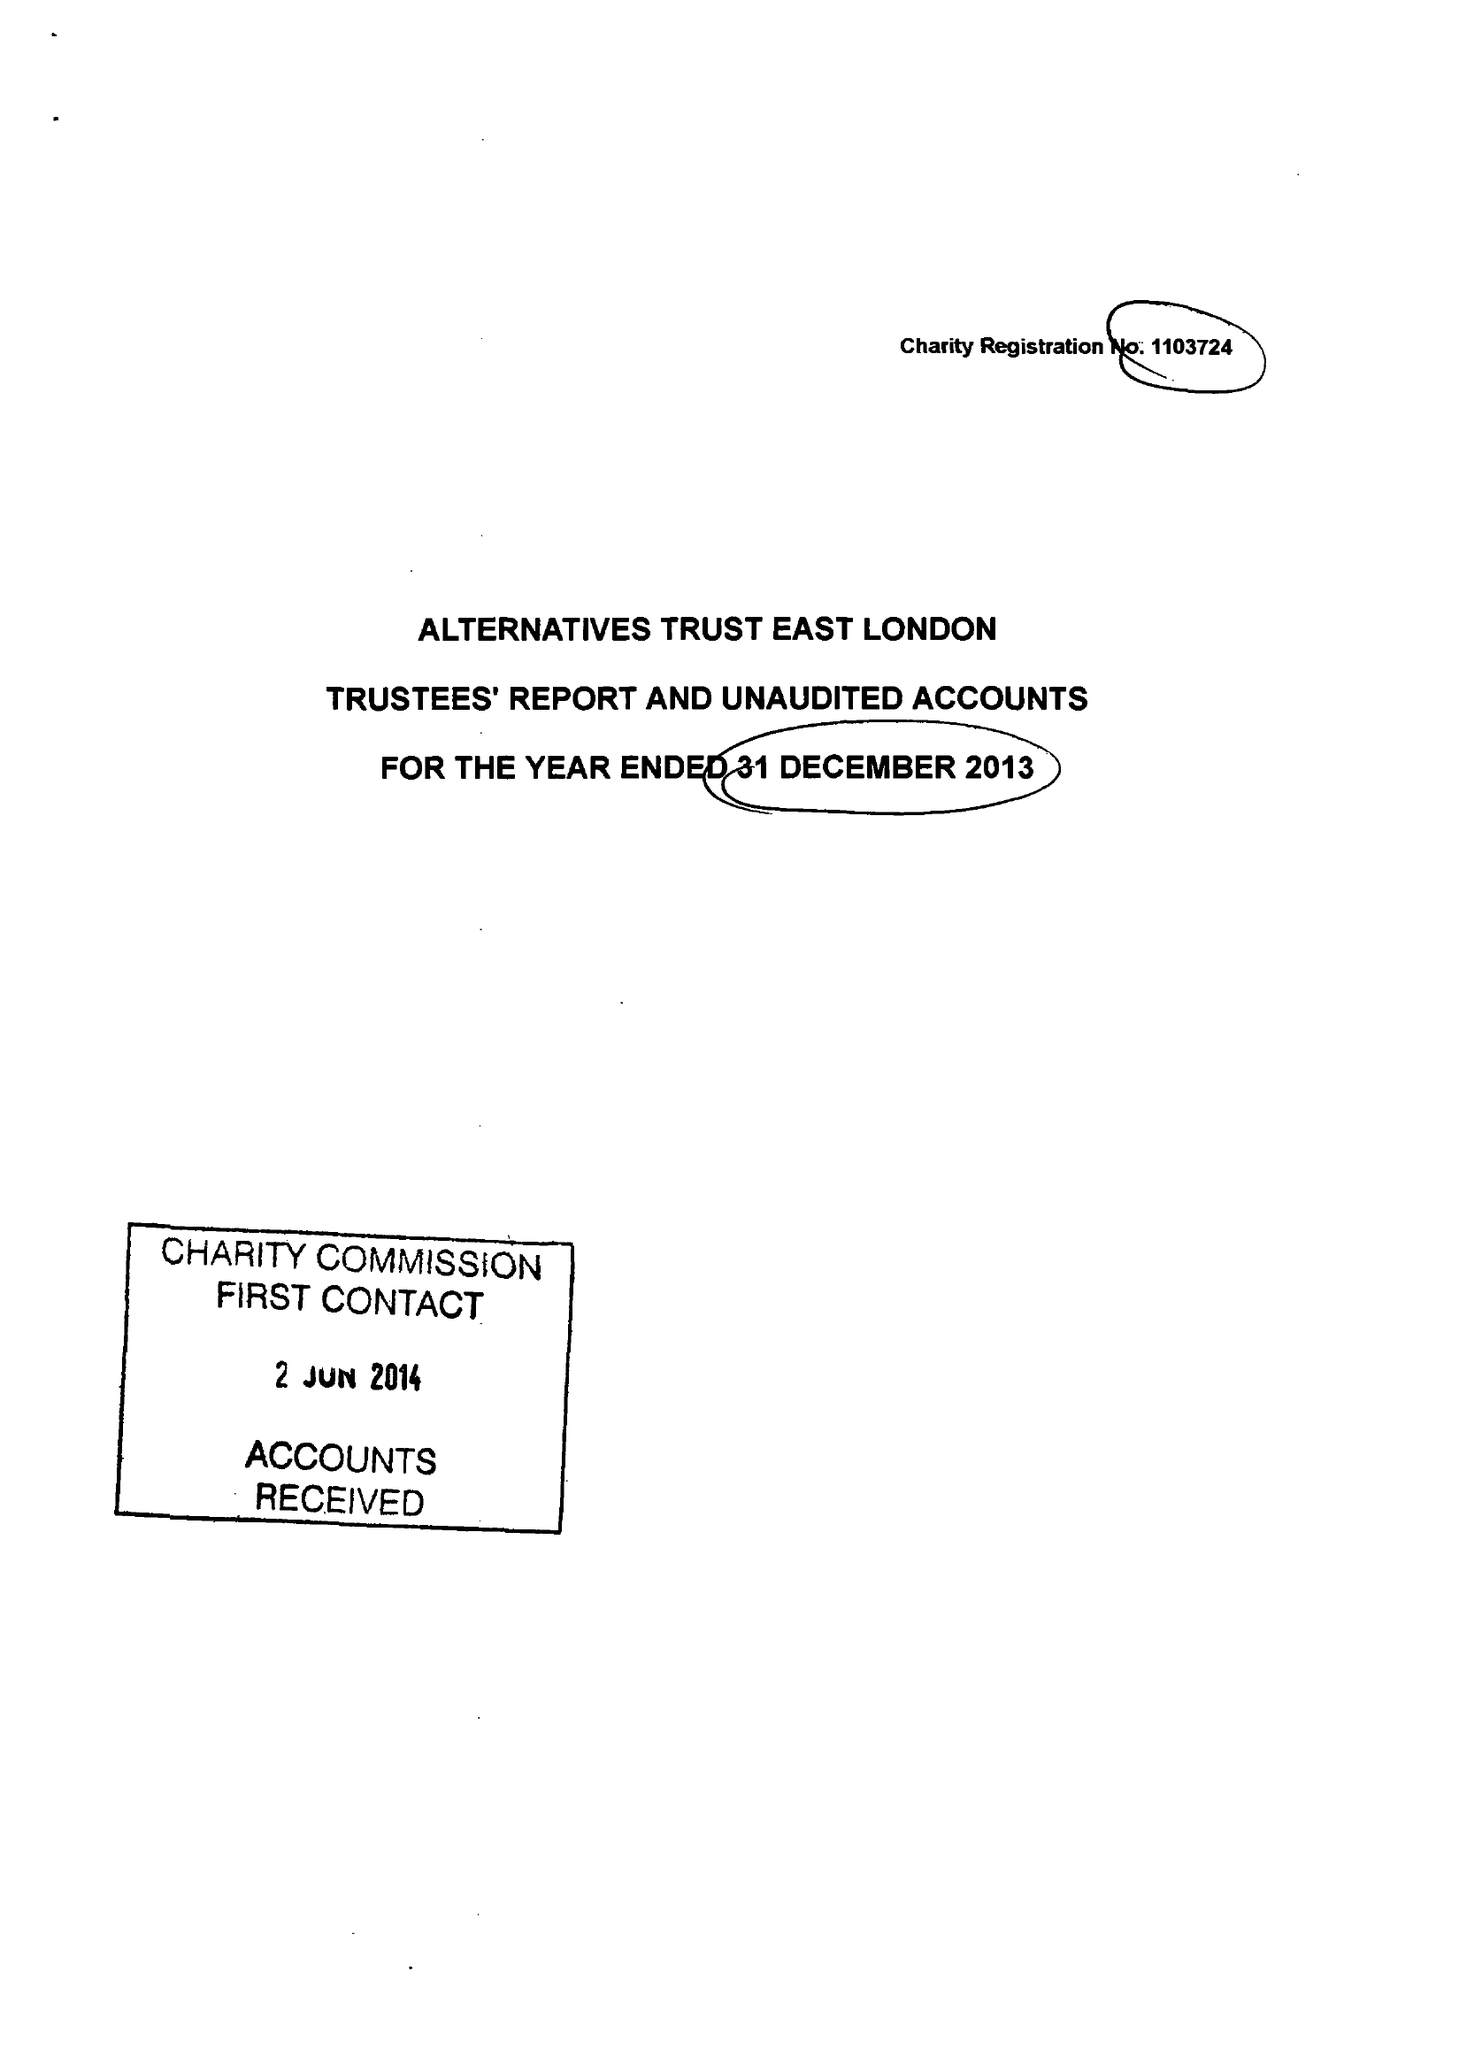What is the value for the charity_name?
Answer the question using a single word or phrase. Alternatives Trust East London 